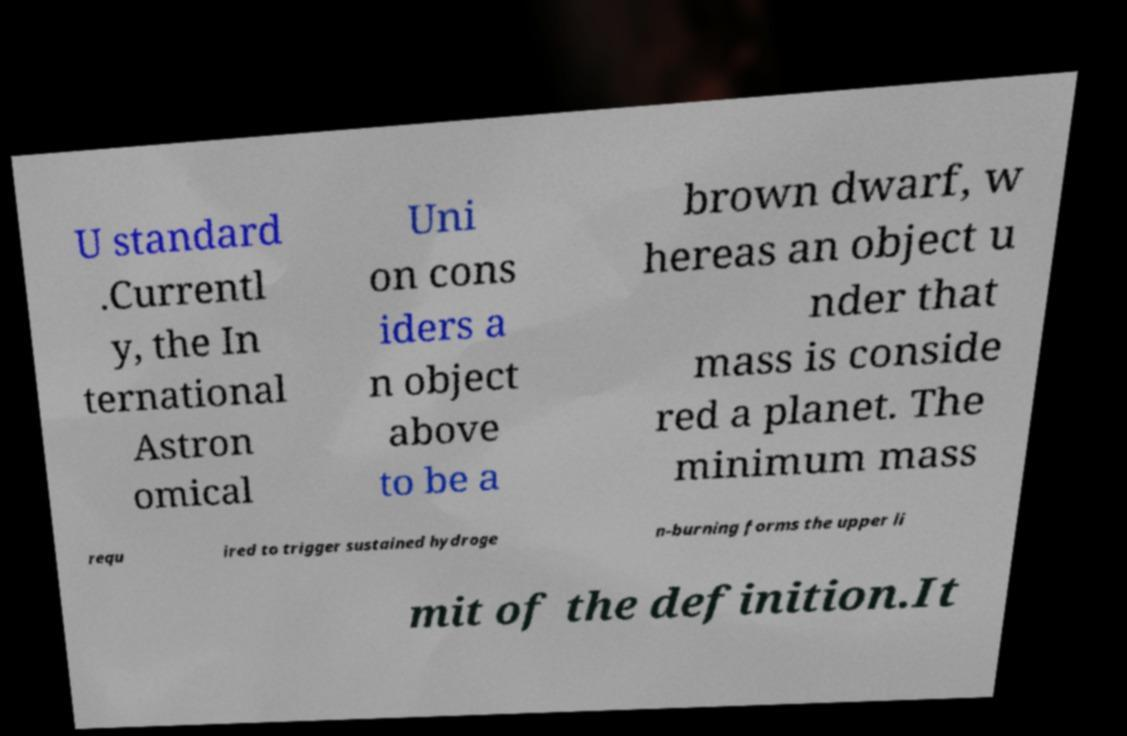Could you assist in decoding the text presented in this image and type it out clearly? U standard .Currentl y, the In ternational Astron omical Uni on cons iders a n object above to be a brown dwarf, w hereas an object u nder that mass is conside red a planet. The minimum mass requ ired to trigger sustained hydroge n-burning forms the upper li mit of the definition.It 